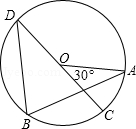Consider the circle O, with A, B, C, D as the four vertices and CD as the diameter. If the degree of angle AOC is 'gamma', determine the degree of angle ABD denoted as 'delta', expressed in terms of 'gamma'. Choices: A: 55° B: 65° C: 75° D: 85° Upon examining the given circle O with vertices A, B, C, and D, where CD is the diameter, we observe that the angle AOC is given as gamma. In circle geometry, the angle subtended by the diameter (angle AOD) is 180°. Therefore, angle AOD is 180° - gamma. Since angle ABD is an inscribed angle that subtends the same arc as angle AOD, it will be half of angle AOD by the Inscribed Angle Theorem. Hence, delta = (1/2)*(180° - gamma). This calculation leads to the conclusion that when gamma equals 30°, delta evaluates to 75°. Thus, the correct choice is C: 75°. 